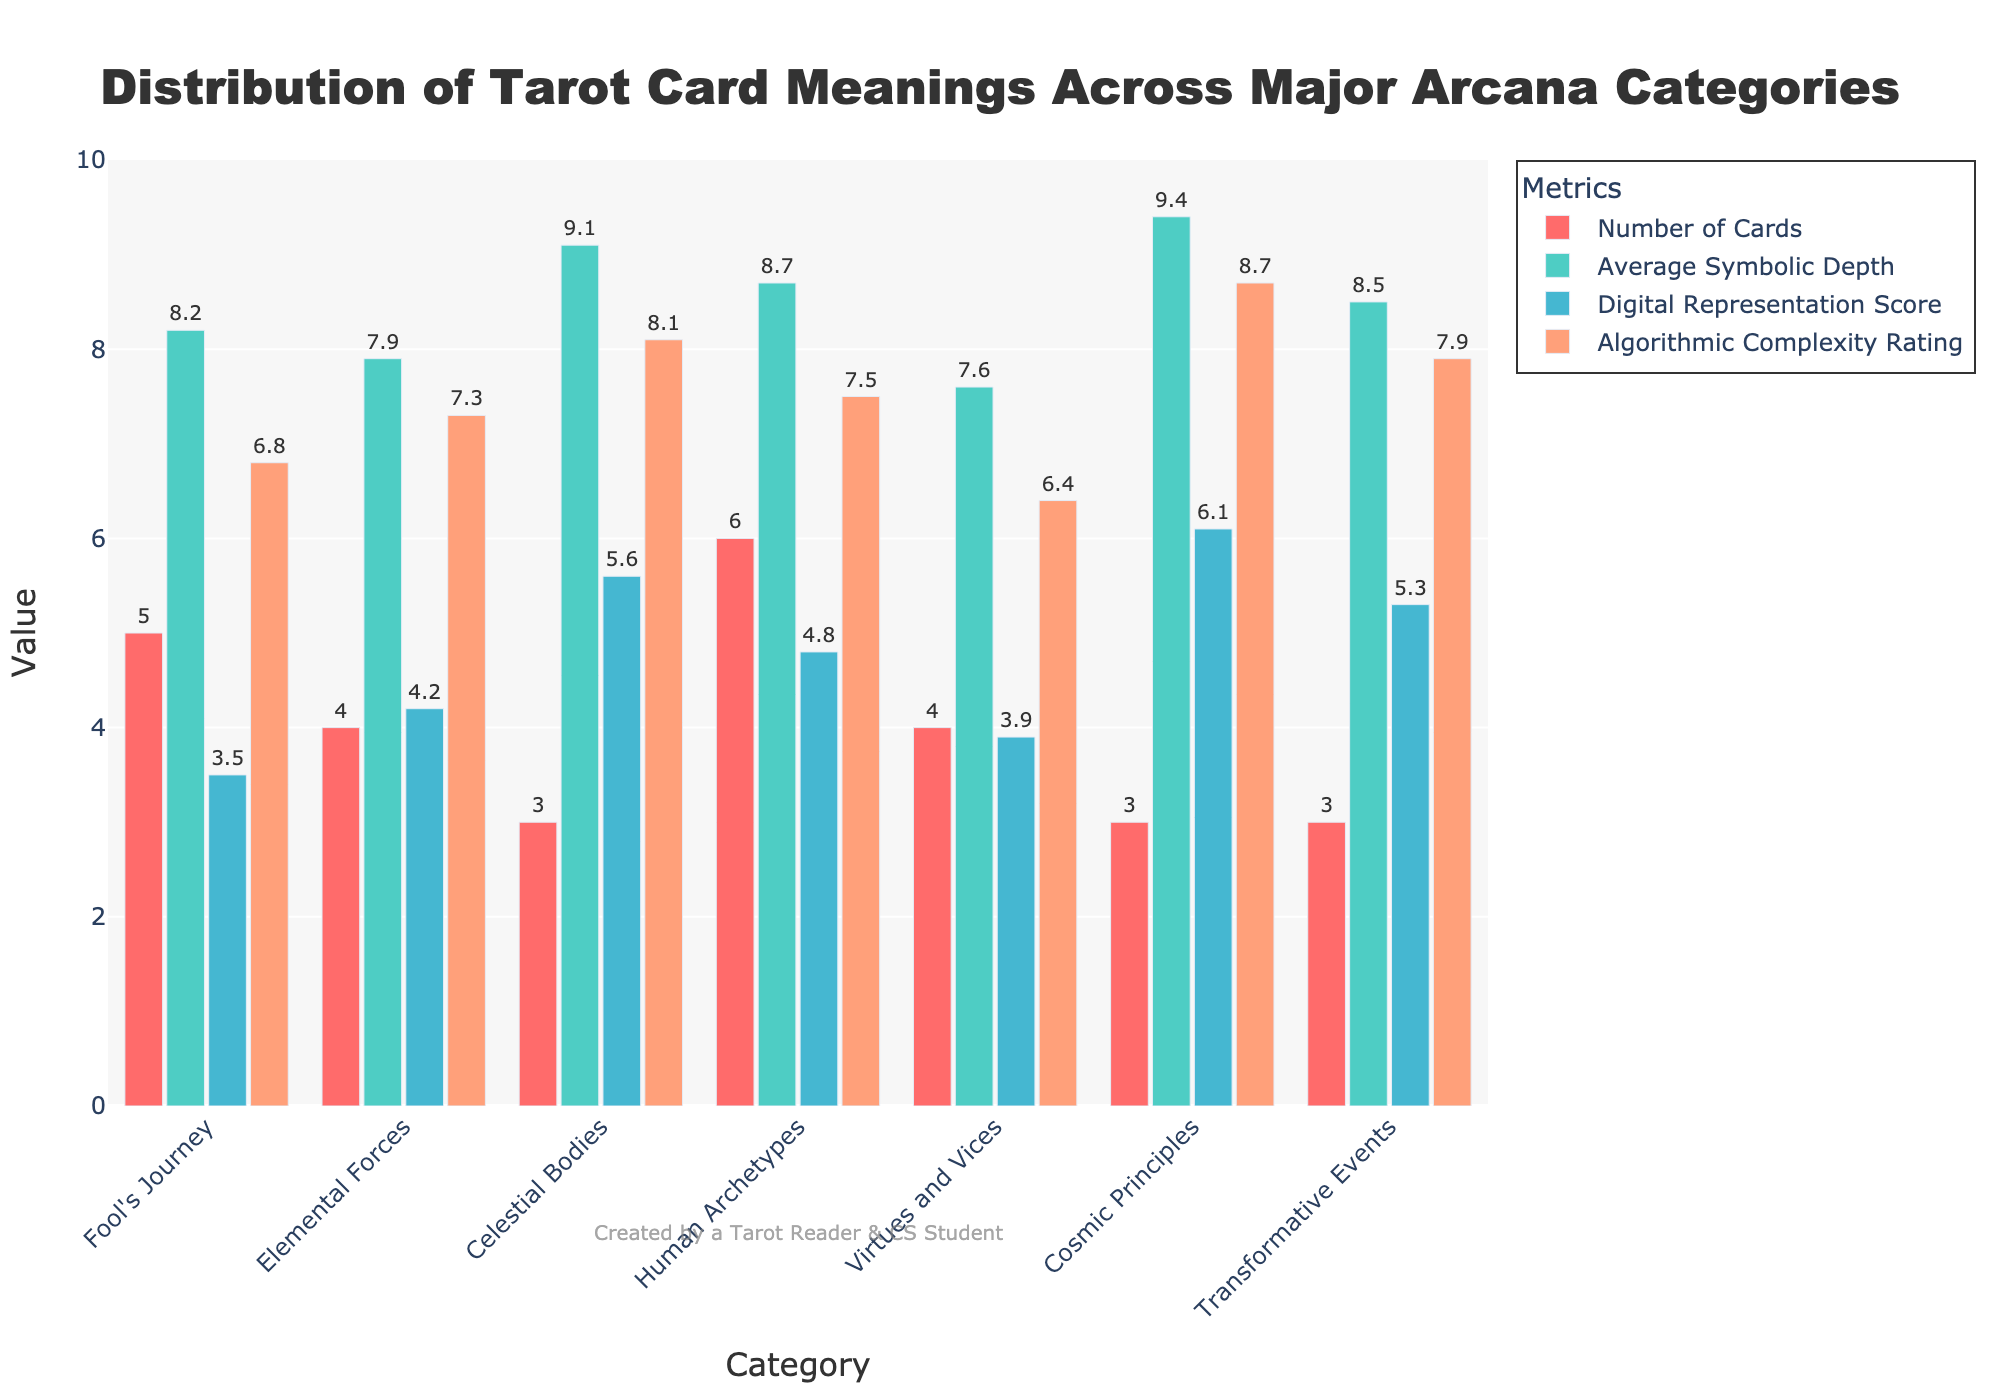What is the total number of cards across all categories? To find the total number of cards, sum the "Number of Cards" for each category: 5 (Fool's Journey) + 4 (Elemental Forces) + 3 (Celestial Bodies) + 6 (Human Archetypes) + 4 (Virtues and Vices) + 3 (Cosmic Principles) + 3 (Transformative Events). This totals to 28 cards.
Answer: 28 Which category has the highest average symbolic depth? Compare the "Average Symbolic Depth" across all categories. Cosmic Principles has the highest value of 9.4.
Answer: Cosmic Principles How does the Algorithmic Complexity Rating of Human Archetypes compare to Transformative Events? Check the values for "Algorithmic Complexity Rating" in the respective categories: Human Archetypes is 7.5, Transformative Events is 7.9. Human Archetypes is lower than Transformative Events.
Answer: Lower What is the average Digital Representation Score for all categories? Sum the "Digital Representation Score" for all categories and divide by the number of categories: (3.5 + 4.2 + 5.6 + 4.8 + 3.9 + 6.1 + 5.3) / 7 = 33.4 / 7 = 4.77.
Answer: 4.77 Which categories have the same number of cards? Compare the "Number of Cards" across the categories. Elemental Forces and Virtues and Vices both have 4 cards, while Celestial Bodies, Cosmic Principles, and Transformative Events each have 3 cards.
Answer: Elemental Forces and Virtues and Vices; Celestial Bodies, Cosmic Principles, and Transformative Events What is the difference in Algorithmic Complexity Rating between the lowest and the highest categories? Find the lowest and highest "Algorithmic Complexity Rating": Virtues and Vices is 6.4 (lowest) and Cosmic Principles is 8.7 (highest). The difference is 8.7 - 6.4 = 2.3.
Answer: 2.3 What is the combined average symbolic depth for Fool's Journey and Virtues and Vices? Sum "Average Symbolic Depth" for Fool's Journey and Virtues and Vices and divide by 2: (8.2 + 7.6) / 2 = 15.8 / 2 = 7.9.
Answer: 7.9 